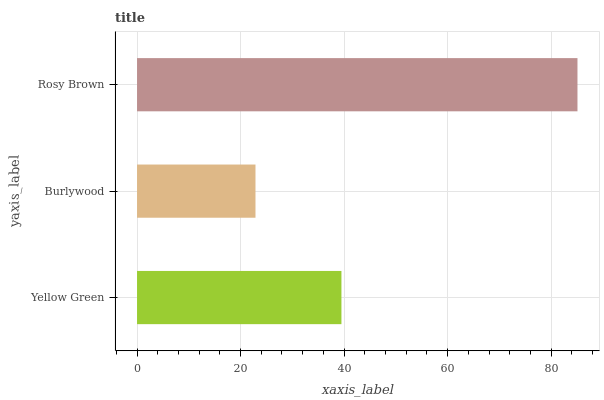Is Burlywood the minimum?
Answer yes or no. Yes. Is Rosy Brown the maximum?
Answer yes or no. Yes. Is Rosy Brown the minimum?
Answer yes or no. No. Is Burlywood the maximum?
Answer yes or no. No. Is Rosy Brown greater than Burlywood?
Answer yes or no. Yes. Is Burlywood less than Rosy Brown?
Answer yes or no. Yes. Is Burlywood greater than Rosy Brown?
Answer yes or no. No. Is Rosy Brown less than Burlywood?
Answer yes or no. No. Is Yellow Green the high median?
Answer yes or no. Yes. Is Yellow Green the low median?
Answer yes or no. Yes. Is Rosy Brown the high median?
Answer yes or no. No. Is Burlywood the low median?
Answer yes or no. No. 